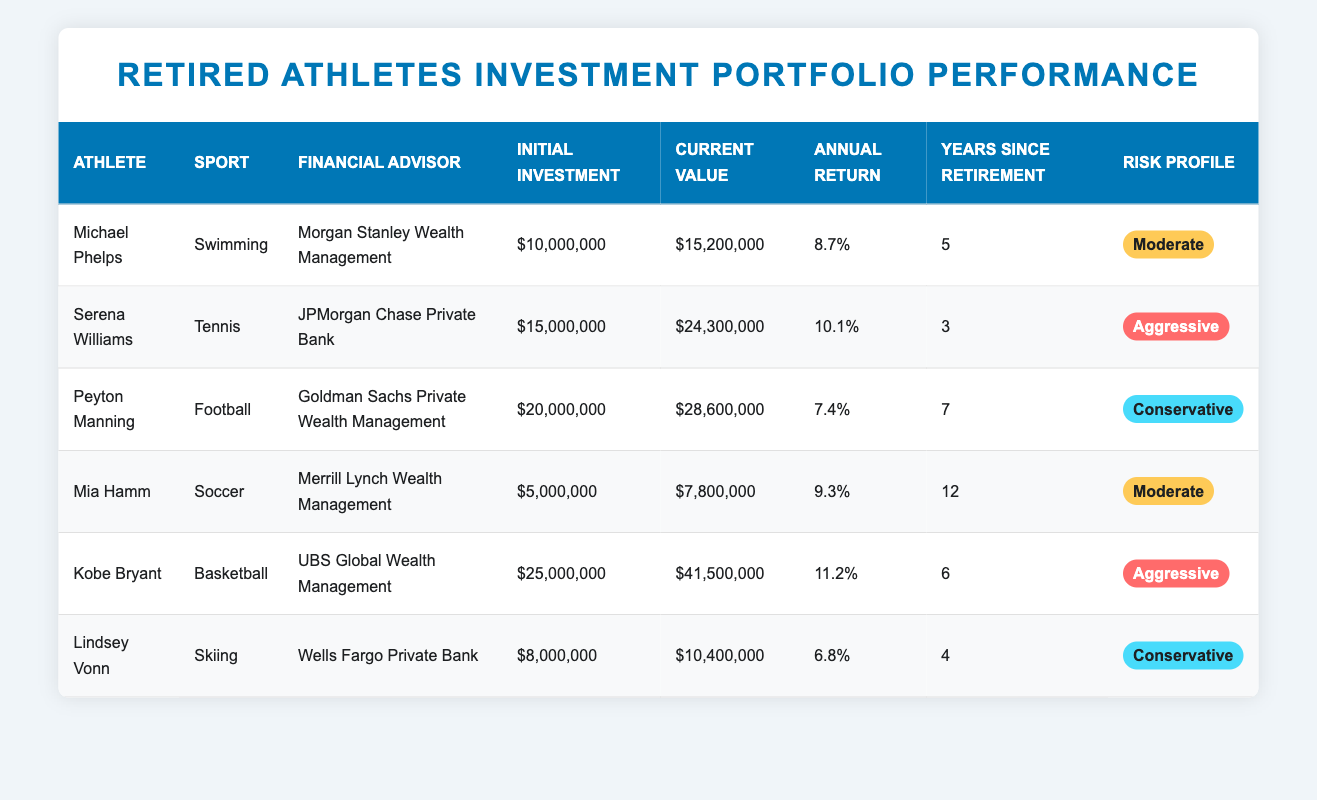What is the current value of Michael Phelps' investment? The table lists Michael Phelps' current value under the "Current Value" column. It shows that his current value is $15,200,000.
Answer: $15,200,000 Which athlete has the highest annual return? By checking the "Annual Return" column, we find Kobe Bryant has the highest annual return at 11.2%.
Answer: Kobe Bryant How much did Serena Williams' investment grow compared to her initial investment? Serena Williams' initial investment was $15,000,000 and her current value is $24,300,000. The growth is calculated as $24,300,000 - $15,000,000 = $9,300,000.
Answer: $9,300,000 Is Lindsey Vonn's risk profile categorized as aggressive? The "Risk Profile" column shows that Lindsey Vonn's risk profile is Conservative, so the answer is no.
Answer: No What is the average annual return of athletes with a moderate risk profile? Michael Phelps has an annual return of 8.7% and Mia Hamm has 9.3%. To find the average, we add them: 8.7 + 9.3 = 18.0, and then divide by 2. The average is 18.0 / 2 = 9.0%.
Answer: 9.0% Which financial advisor is managing Peyton Manning's investment? You can find Peyton Manning's advisor under the "Financial Advisor" column, which lists Goldman Sachs Private Wealth Management.
Answer: Goldman Sachs Private Wealth Management How many years has Kobe Bryant been retired? Looking at the "Years Since Retirement" column, Kobe Bryant has been retired for 6 years.
Answer: 6 years What is the difference in current value between the athlete with the highest investment and the one with the lowest? The highest initial investment is Kobe Bryant with $25,000,000, and the lowest is Mia Hamm with $5,000,000. Their current values are $41,500,000 and $7,800,000 respectively. The difference in current value between these two athletes is calculated by subtracting Mia Hamm's current value from Kobe Bryant’s: $41,500,000 - $7,800,000 = $33,700,000.
Answer: $33,700,000 Who has been retired the longest among the athletes listed? By checking the "Years Since Retirement" column, Mia Hamm shows 12 years, which is the highest compared to the other athletes.
Answer: Mia Hamm 